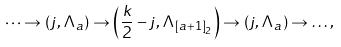Convert formula to latex. <formula><loc_0><loc_0><loc_500><loc_500>\dots \rightarrow \left ( j , \Lambda _ { a } \right ) \rightarrow \left ( \frac { k } { 2 } - j , \Lambda _ { \left [ a + 1 \right ] _ { 2 } } \right ) \rightarrow \left ( j , \Lambda _ { a } \right ) \rightarrow \dots ,</formula> 